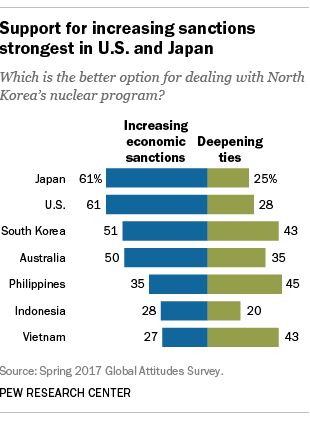Draw attention to some important aspects in this diagram. The color of all the bars on the right-side is green. The average of all the green bars is less than the median of the blue bar. 